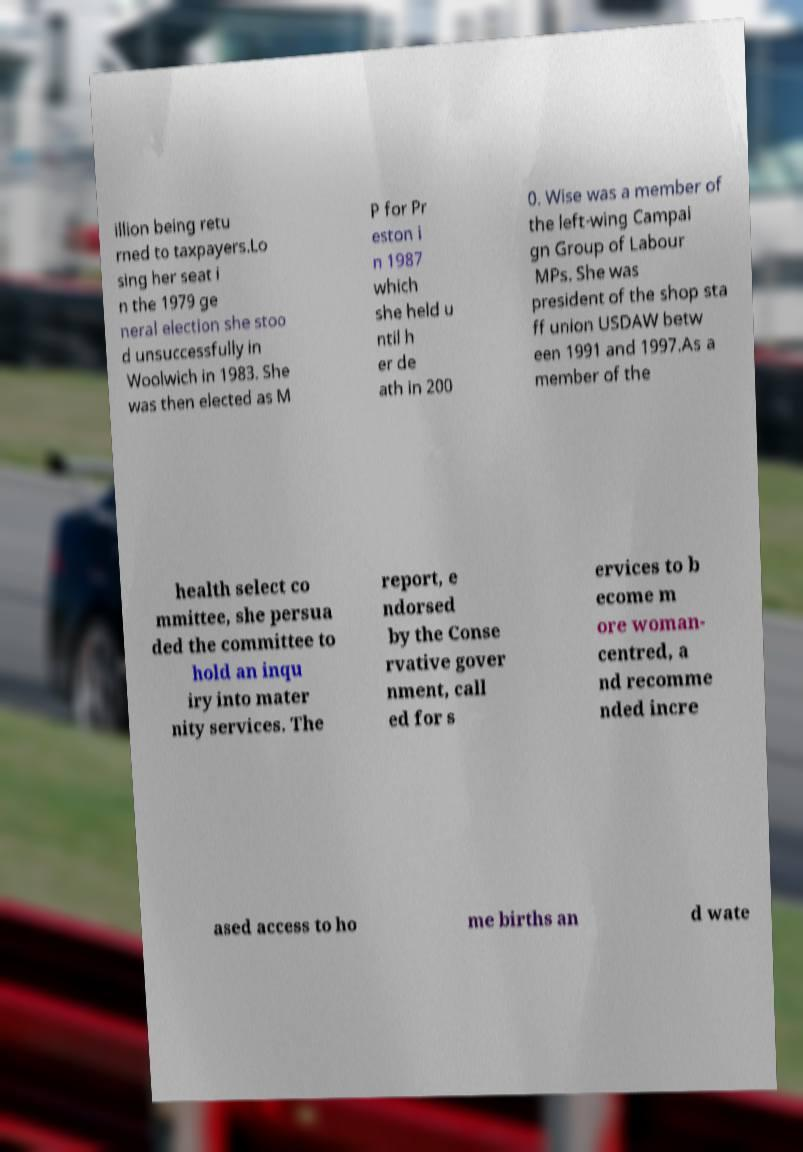Please identify and transcribe the text found in this image. illion being retu rned to taxpayers.Lo sing her seat i n the 1979 ge neral election she stoo d unsuccessfully in Woolwich in 1983. She was then elected as M P for Pr eston i n 1987 which she held u ntil h er de ath in 200 0. Wise was a member of the left-wing Campai gn Group of Labour MPs. She was president of the shop sta ff union USDAW betw een 1991 and 1997.As a member of the health select co mmittee, she persua ded the committee to hold an inqu iry into mater nity services. The report, e ndorsed by the Conse rvative gover nment, call ed for s ervices to b ecome m ore woman- centred, a nd recomme nded incre ased access to ho me births an d wate 